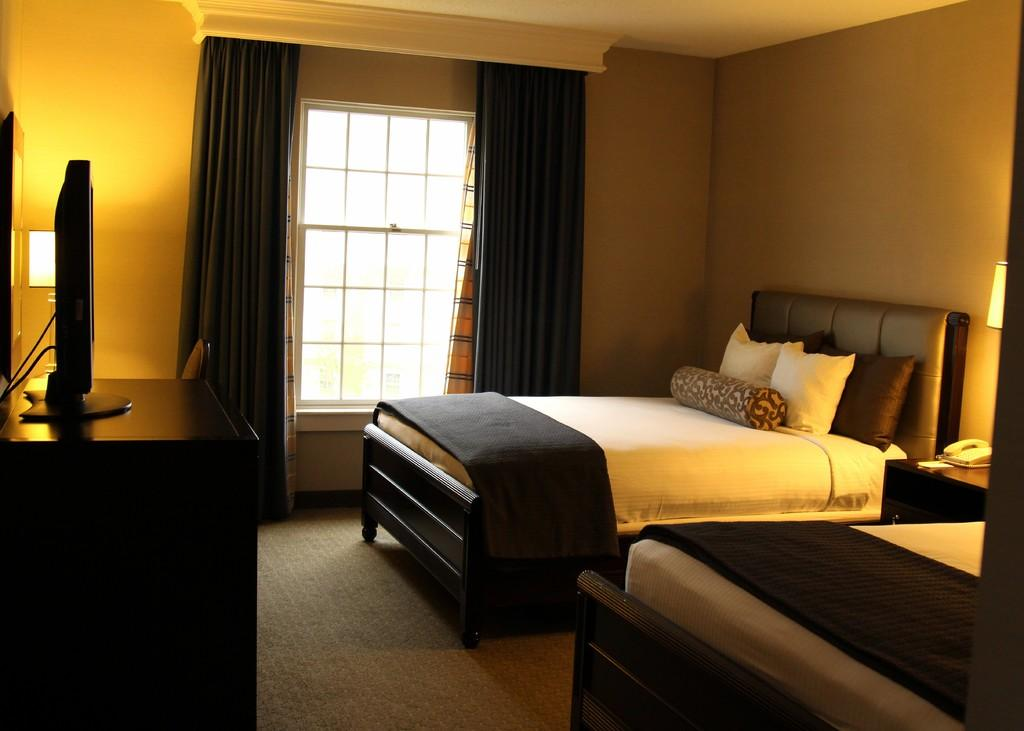What can be seen in the image that allows light to enter the room? There is a window in the image. What is used to cover the window? There are curtains associated with the window. What color is the wall in the image? The wall is yellow in color. What type of system is present in the image? There is a system (possibly a computer or electronic device) in the image. What type of furniture is in the image? There is a bed in the image. What is placed on the bed for comfort? There are pillows on the bed. Can you see someone jumping on the bed in the image? There is no one jumping on the bed in the image. What type of nail is being hammered into the wall in the image? There is no nail being hammered into the wall in the image. 